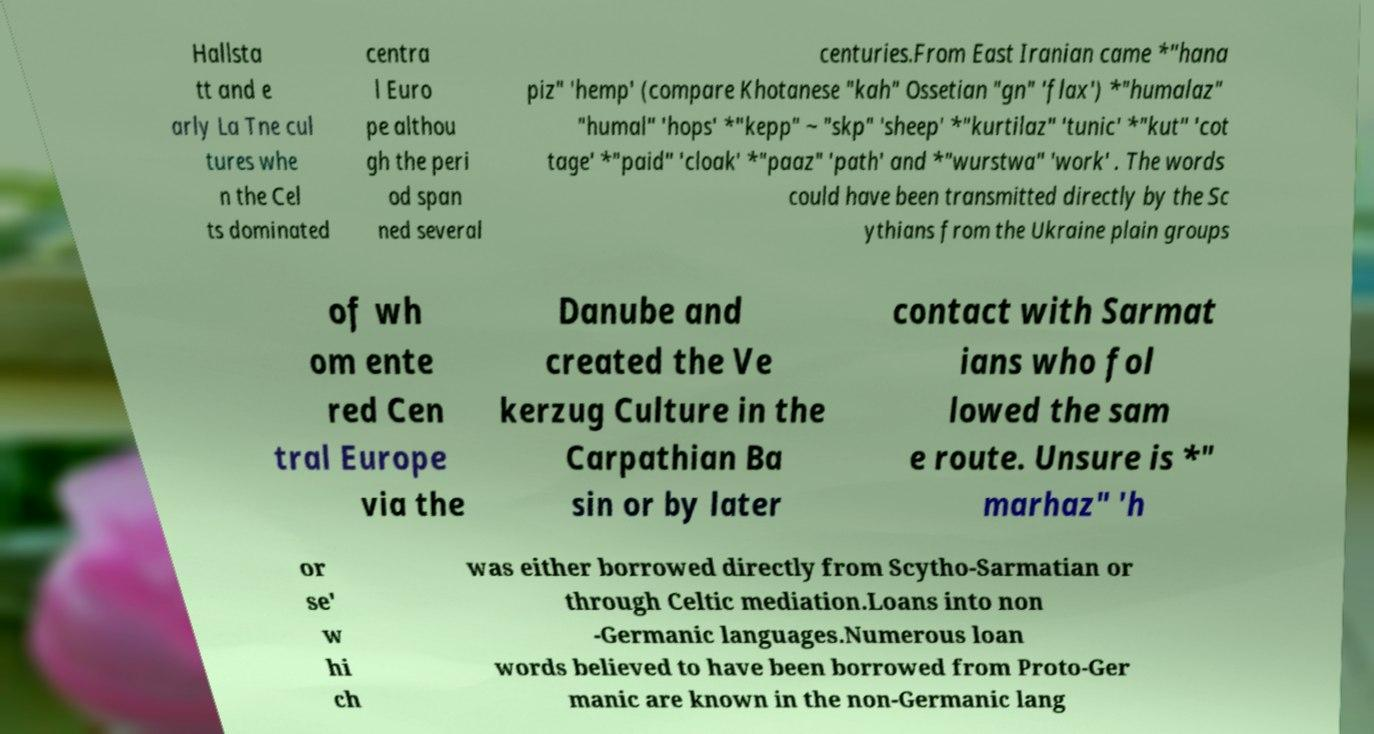Please read and relay the text visible in this image. What does it say? Hallsta tt and e arly La Tne cul tures whe n the Cel ts dominated centra l Euro pe althou gh the peri od span ned several centuries.From East Iranian came *"hana piz" 'hemp' (compare Khotanese "kah" Ossetian "gn" 'flax') *"humalaz" "humal" 'hops' *"kepp" ~ "skp" 'sheep' *"kurtilaz" 'tunic' *"kut" 'cot tage' *"paid" 'cloak' *"paaz" 'path' and *"wurstwa" 'work' . The words could have been transmitted directly by the Sc ythians from the Ukraine plain groups of wh om ente red Cen tral Europe via the Danube and created the Ve kerzug Culture in the Carpathian Ba sin or by later contact with Sarmat ians who fol lowed the sam e route. Unsure is *" marhaz" 'h or se' w hi ch was either borrowed directly from Scytho-Sarmatian or through Celtic mediation.Loans into non -Germanic languages.Numerous loan words believed to have been borrowed from Proto-Ger manic are known in the non-Germanic lang 